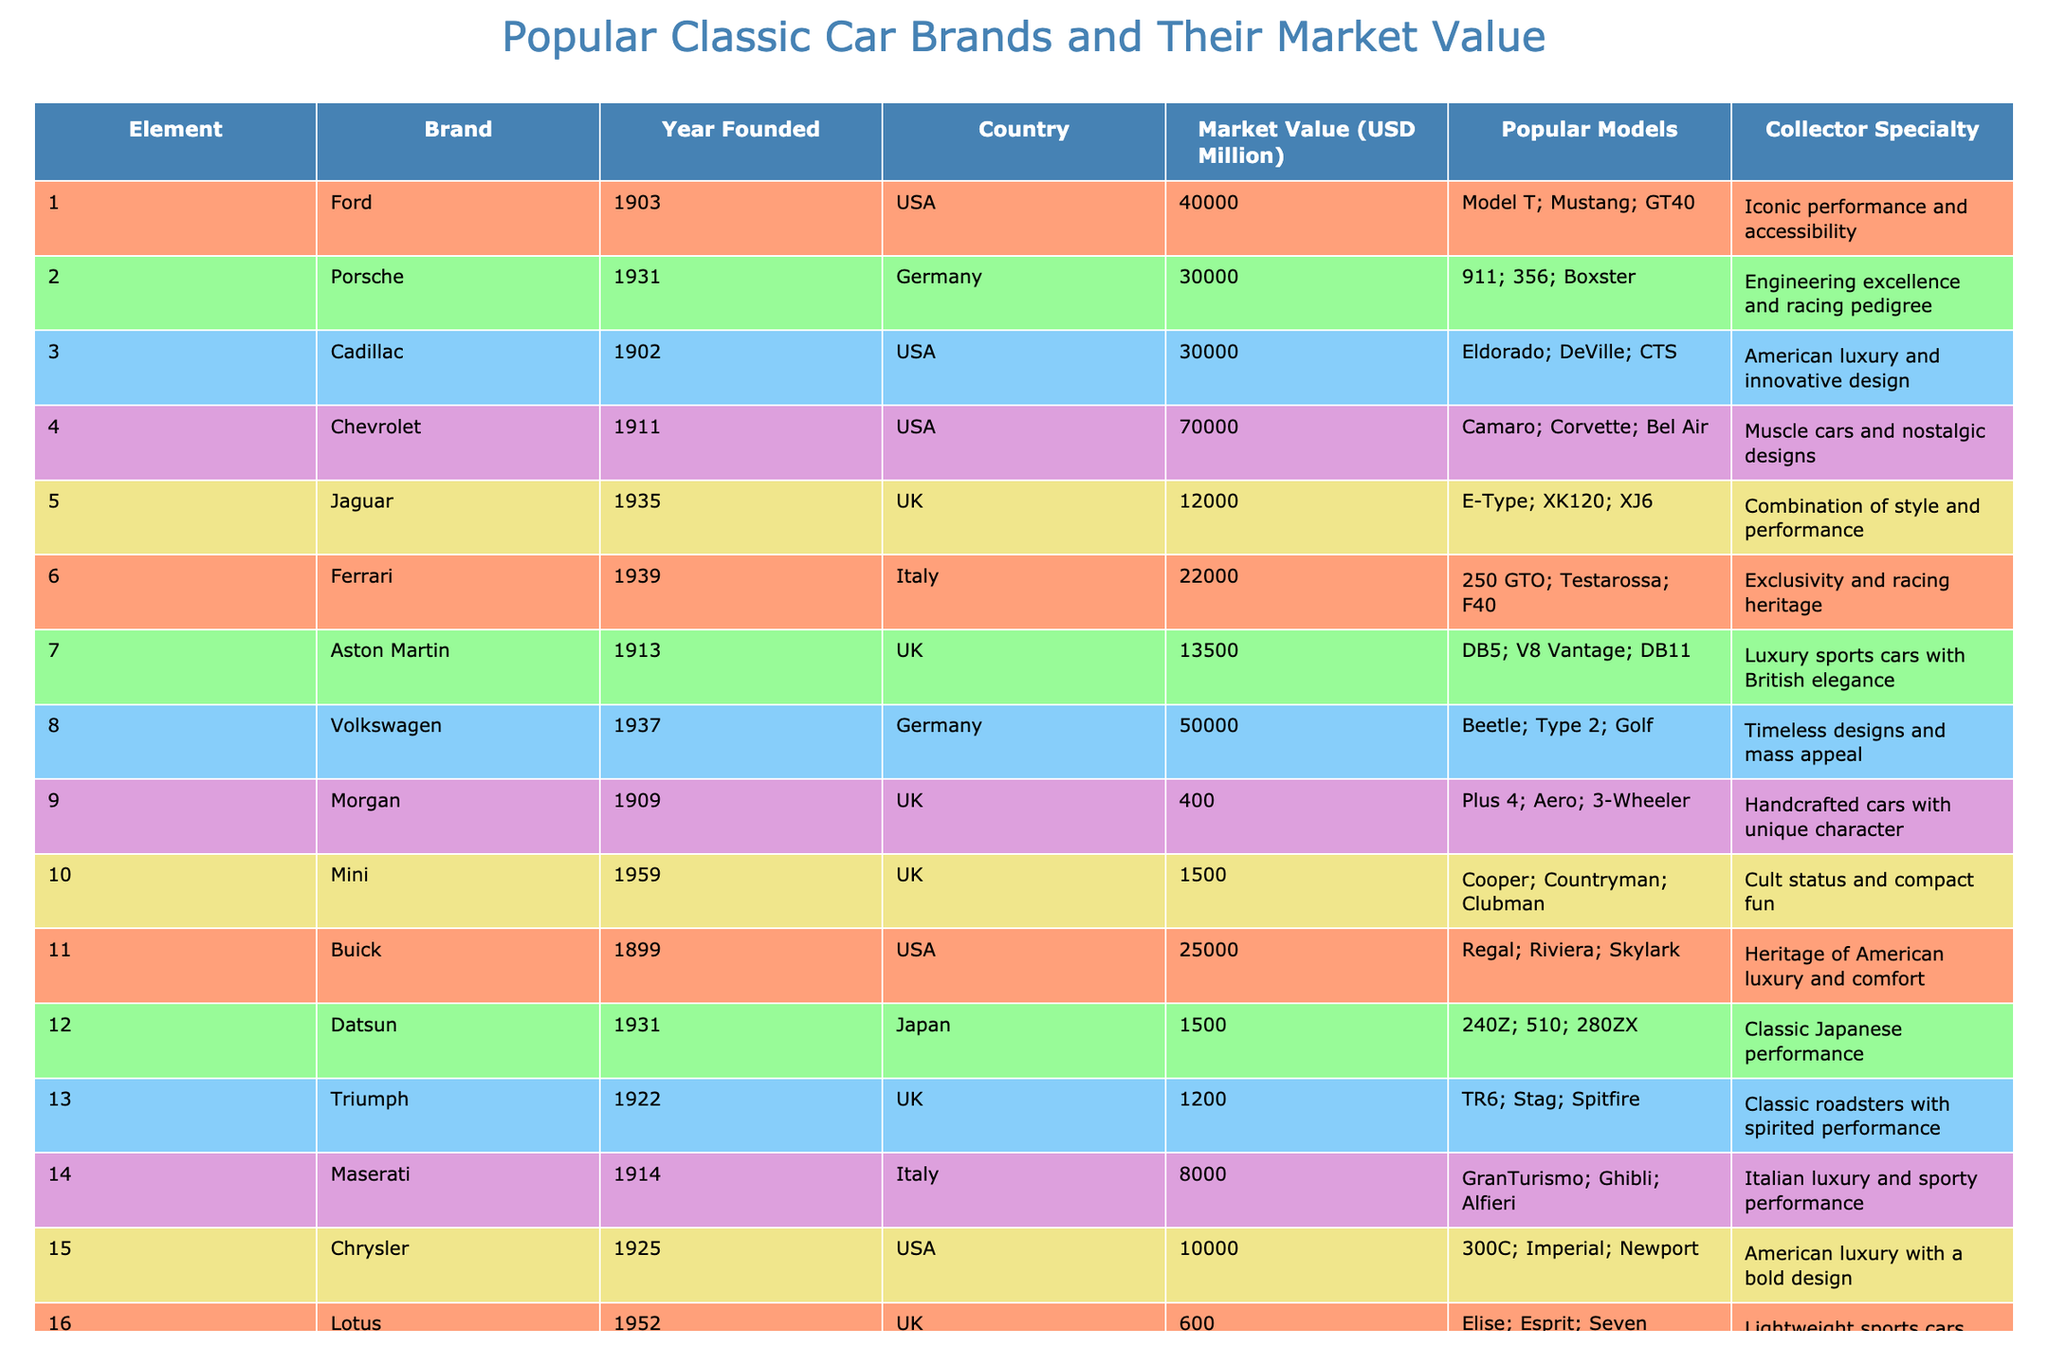What is the market value of Chevrolet? From the table, the market value of Chevrolet is listed under the corresponding column. Therefore, I simply look for Chevrolet in the Brand column and find its market value in the Market Value (USD Million) column. The value is 70000 million USD.
Answer: 70000 million USD Which brand has the highest market value? To determine the highest market value, I compare all the values in the Market Value (USD Million) column. The highest value is 100000 for Mercedes-Benz.
Answer: Mercedes-Benz Is Ford older than Aston Martin? I will check the Year Founded for both brands: Ford was founded in 1903 and Aston Martin in 1913. Since 1903 is earlier than 1913, Ford is indeed older.
Answer: Yes What is the average market value of the top three classic car brands? First, I identify the top three brands by their market value: Mercedes-Benz (100000), Chevrolet (70000), and Ford (40000). Then, I sum those values: 100000 + 70000 + 40000 = 210000. Finally, I divide by 3 to get the average: 210000 / 3 = 70000.
Answer: 70000 million USD Which country has the most brands listed in the table? I count the number of brands per country. USA has 5 brands (Ford, Cadillac, Chevrolet, Buick, and Chrysler), UK has 5 brands (Jaguar, Aston Martin, Morgan, Mini, and Triumph), Germany has 3 brands (Porsche, Volkswagen, and Mercedes-Benz), Italy has 3 brands (Ferrari, Maserati, and Alfa Romeo), Japan has 1 brand (Datsun), and France has 1 brand (Peugeot). Since both the USA and UK have the same highest count, the answer is both.
Answer: USA and UK What is the market value difference between Porsche and Jaguar? I look at the Market Value (USD Million) for each brand: Porsche is valued at 30000 million USD and Jaguar at 12000 million USD. To find the difference, I subtract Jaguar’s value from Porsche’s: 30000 - 12000 = 18000.
Answer: 18000 million USD Does Datsun have a higher market value than Morgan? I check the Market Value for Datsun (1500 million USD) and Morgan (400 million USD). Since 1500 is greater than 400, Datsun indeed has a higher market value than Morgan.
Answer: Yes What is the total market value of all brands from the USA? To find the total market value, I sum the values for all US brands: Ford (40000), Cadillac (30000), Chevrolet (70000), Buick (25000), and Chrysler (10000). So, the total is: 40000 + 30000 + 70000 + 25000 + 10000 = 175000 million USD.
Answer: 175000 million USD How many brands have a market value over 20000 million USD? I examine the Market Value column and count brands exceeding 20000 million USD: Chevrolet (70000), Ford (40000), Mercedes-Benz (100000), and Porsche (30000). That gives a total of 4 brands over 20000 million USD.
Answer: 4 